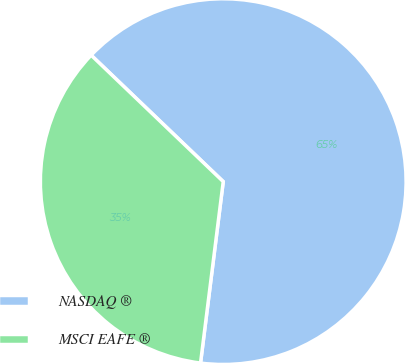<chart> <loc_0><loc_0><loc_500><loc_500><pie_chart><fcel>NASDAQ ®<fcel>MSCI EAFE ®<nl><fcel>64.83%<fcel>35.17%<nl></chart> 